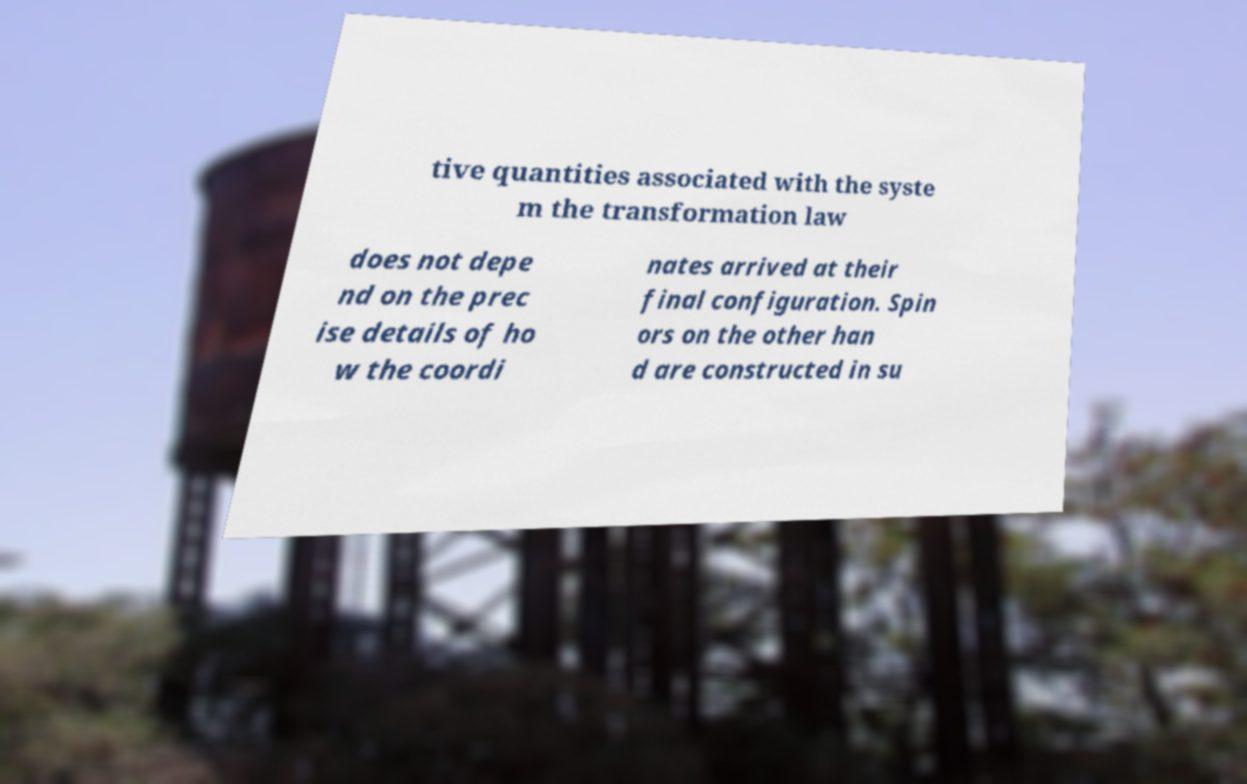Can you read and provide the text displayed in the image?This photo seems to have some interesting text. Can you extract and type it out for me? tive quantities associated with the syste m the transformation law does not depe nd on the prec ise details of ho w the coordi nates arrived at their final configuration. Spin ors on the other han d are constructed in su 